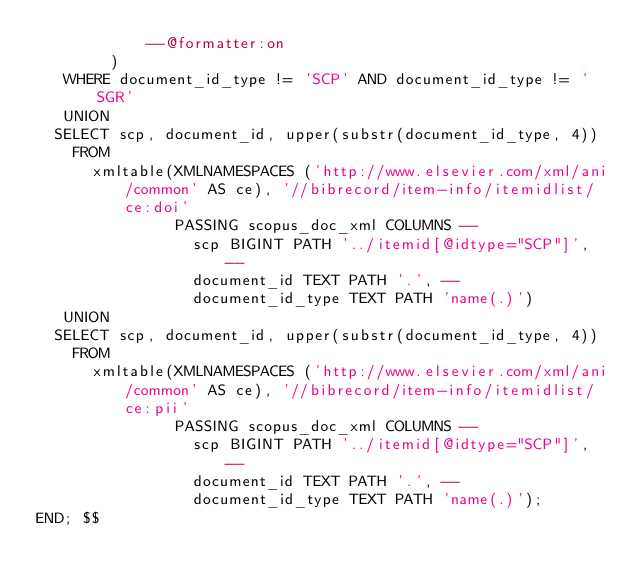Convert code to text. <code><loc_0><loc_0><loc_500><loc_500><_SQL_>            --@formatter:on
        )
   WHERE document_id_type != 'SCP' AND document_id_type != 'SGR'
   UNION
  SELECT scp, document_id, upper(substr(document_id_type, 4))
    FROM
      xmltable(XMLNAMESPACES ('http://www.elsevier.com/xml/ani/common' AS ce), '//bibrecord/item-info/itemidlist/ce:doi'
               PASSING scopus_doc_xml COLUMNS --
                 scp BIGINT PATH '../itemid[@idtype="SCP"]', --
                 document_id TEXT PATH '.', --
                 document_id_type TEXT PATH 'name(.)')
   UNION
  SELECT scp, document_id, upper(substr(document_id_type, 4))
    FROM
      xmltable(XMLNAMESPACES ('http://www.elsevier.com/xml/ani/common' AS ce), '//bibrecord/item-info/itemidlist/ce:pii'
               PASSING scopus_doc_xml COLUMNS --
                 scp BIGINT PATH '../itemid[@idtype="SCP"]', --
                 document_id TEXT PATH '.', --
                 document_id_type TEXT PATH 'name(.)');
END; $$

</code> 